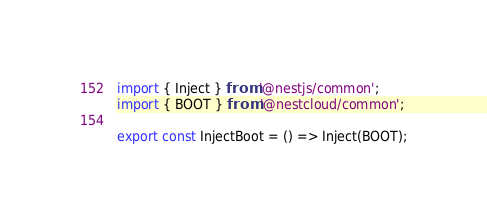Convert code to text. <code><loc_0><loc_0><loc_500><loc_500><_TypeScript_>import { Inject } from '@nestjs/common';
import { BOOT } from '@nestcloud/common';

export const InjectBoot = () => Inject(BOOT);
</code> 